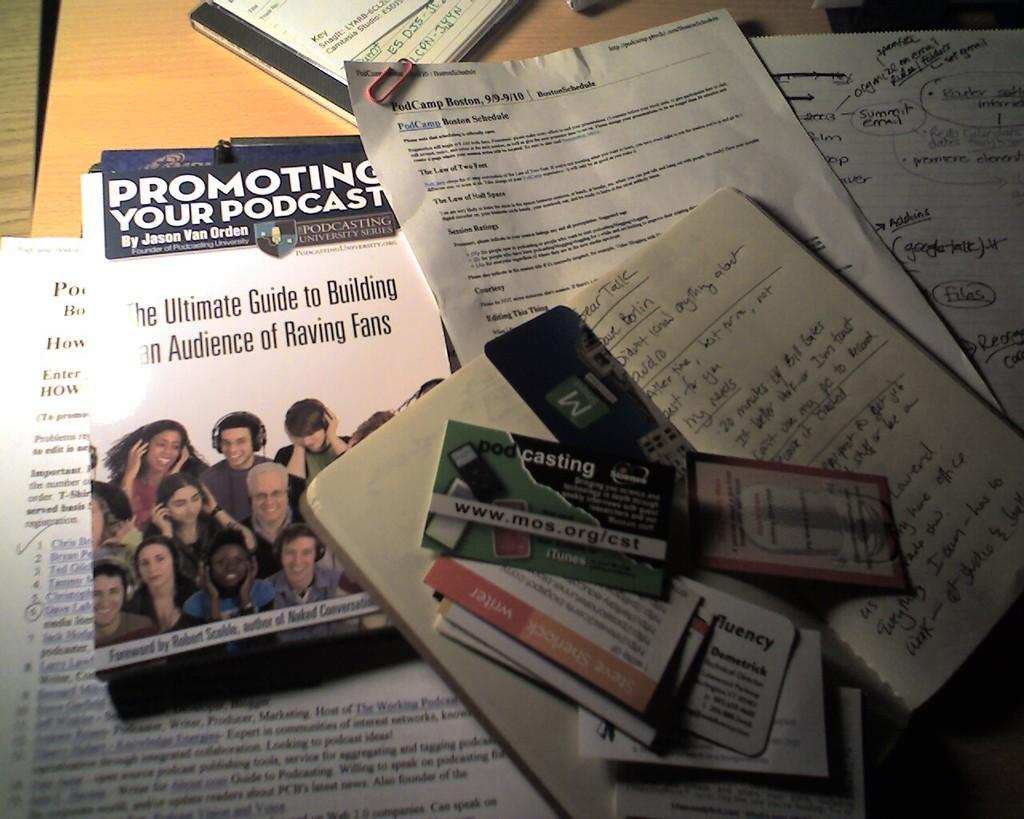<image>
Render a clear and concise summary of the photo. A book about promoting your podcast sits near some scattered business cards. 